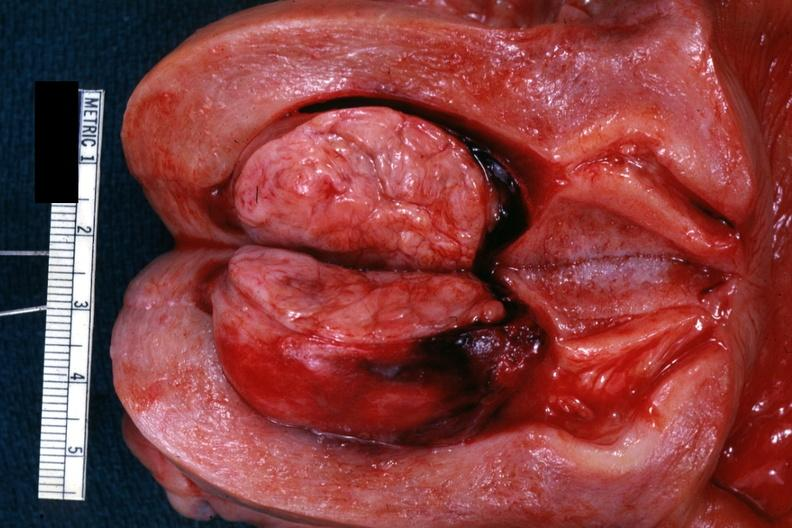s uterus present?
Answer the question using a single word or phrase. Yes 